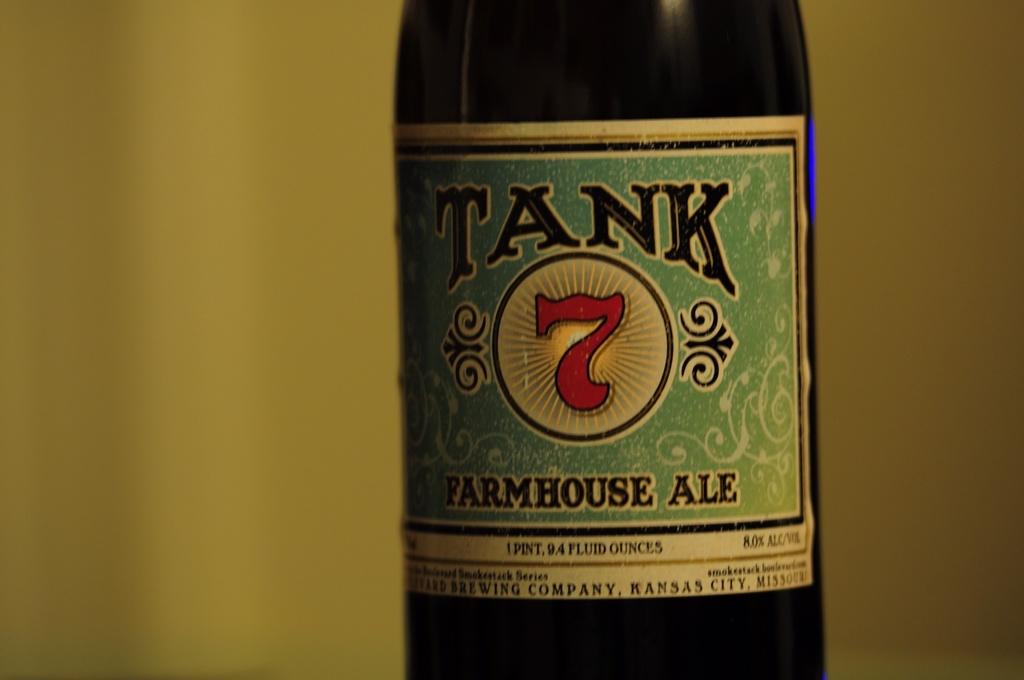What kind of ale is this?
Your answer should be very brief. Farmhouse ale. Is tank farmhouse ale an ipa?
Make the answer very short. No. 